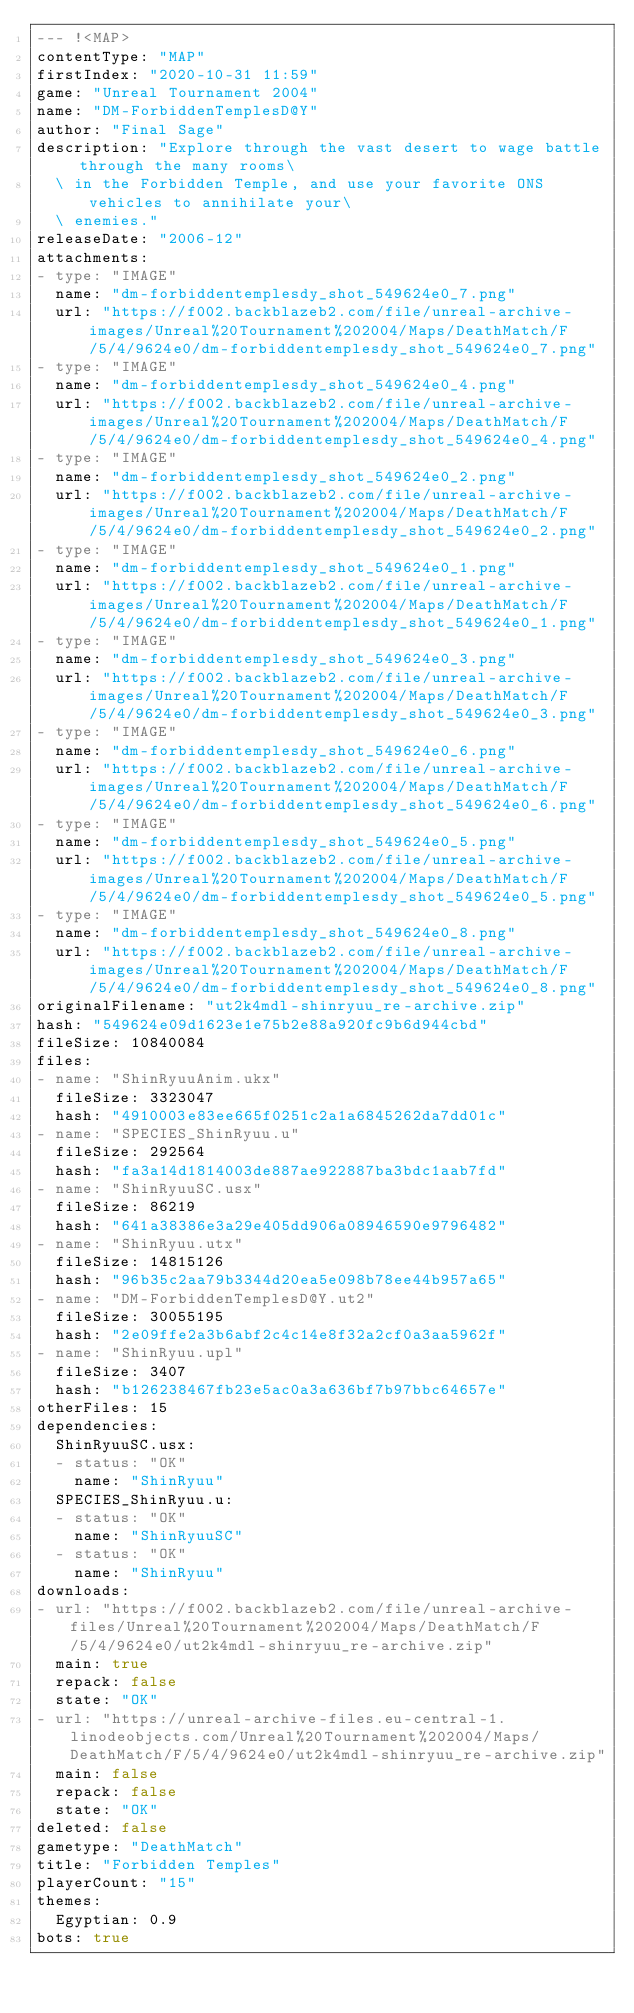<code> <loc_0><loc_0><loc_500><loc_500><_YAML_>--- !<MAP>
contentType: "MAP"
firstIndex: "2020-10-31 11:59"
game: "Unreal Tournament 2004"
name: "DM-ForbiddenTemplesD@Y"
author: "Final Sage"
description: "Explore through the vast desert to wage battle through the many rooms\
  \ in the Forbidden Temple, and use your favorite ONS vehicles to annihilate your\
  \ enemies."
releaseDate: "2006-12"
attachments:
- type: "IMAGE"
  name: "dm-forbiddentemplesdy_shot_549624e0_7.png"
  url: "https://f002.backblazeb2.com/file/unreal-archive-images/Unreal%20Tournament%202004/Maps/DeathMatch/F/5/4/9624e0/dm-forbiddentemplesdy_shot_549624e0_7.png"
- type: "IMAGE"
  name: "dm-forbiddentemplesdy_shot_549624e0_4.png"
  url: "https://f002.backblazeb2.com/file/unreal-archive-images/Unreal%20Tournament%202004/Maps/DeathMatch/F/5/4/9624e0/dm-forbiddentemplesdy_shot_549624e0_4.png"
- type: "IMAGE"
  name: "dm-forbiddentemplesdy_shot_549624e0_2.png"
  url: "https://f002.backblazeb2.com/file/unreal-archive-images/Unreal%20Tournament%202004/Maps/DeathMatch/F/5/4/9624e0/dm-forbiddentemplesdy_shot_549624e0_2.png"
- type: "IMAGE"
  name: "dm-forbiddentemplesdy_shot_549624e0_1.png"
  url: "https://f002.backblazeb2.com/file/unreal-archive-images/Unreal%20Tournament%202004/Maps/DeathMatch/F/5/4/9624e0/dm-forbiddentemplesdy_shot_549624e0_1.png"
- type: "IMAGE"
  name: "dm-forbiddentemplesdy_shot_549624e0_3.png"
  url: "https://f002.backblazeb2.com/file/unreal-archive-images/Unreal%20Tournament%202004/Maps/DeathMatch/F/5/4/9624e0/dm-forbiddentemplesdy_shot_549624e0_3.png"
- type: "IMAGE"
  name: "dm-forbiddentemplesdy_shot_549624e0_6.png"
  url: "https://f002.backblazeb2.com/file/unreal-archive-images/Unreal%20Tournament%202004/Maps/DeathMatch/F/5/4/9624e0/dm-forbiddentemplesdy_shot_549624e0_6.png"
- type: "IMAGE"
  name: "dm-forbiddentemplesdy_shot_549624e0_5.png"
  url: "https://f002.backblazeb2.com/file/unreal-archive-images/Unreal%20Tournament%202004/Maps/DeathMatch/F/5/4/9624e0/dm-forbiddentemplesdy_shot_549624e0_5.png"
- type: "IMAGE"
  name: "dm-forbiddentemplesdy_shot_549624e0_8.png"
  url: "https://f002.backblazeb2.com/file/unreal-archive-images/Unreal%20Tournament%202004/Maps/DeathMatch/F/5/4/9624e0/dm-forbiddentemplesdy_shot_549624e0_8.png"
originalFilename: "ut2k4mdl-shinryuu_re-archive.zip"
hash: "549624e09d1623e1e75b2e88a920fc9b6d944cbd"
fileSize: 10840084
files:
- name: "ShinRyuuAnim.ukx"
  fileSize: 3323047
  hash: "4910003e83ee665f0251c2a1a6845262da7dd01c"
- name: "SPECIES_ShinRyuu.u"
  fileSize: 292564
  hash: "fa3a14d1814003de887ae922887ba3bdc1aab7fd"
- name: "ShinRyuuSC.usx"
  fileSize: 86219
  hash: "641a38386e3a29e405dd906a08946590e9796482"
- name: "ShinRyuu.utx"
  fileSize: 14815126
  hash: "96b35c2aa79b3344d20ea5e098b78ee44b957a65"
- name: "DM-ForbiddenTemplesD@Y.ut2"
  fileSize: 30055195
  hash: "2e09ffe2a3b6abf2c4c14e8f32a2cf0a3aa5962f"
- name: "ShinRyuu.upl"
  fileSize: 3407
  hash: "b126238467fb23e5ac0a3a636bf7b97bbc64657e"
otherFiles: 15
dependencies:
  ShinRyuuSC.usx:
  - status: "OK"
    name: "ShinRyuu"
  SPECIES_ShinRyuu.u:
  - status: "OK"
    name: "ShinRyuuSC"
  - status: "OK"
    name: "ShinRyuu"
downloads:
- url: "https://f002.backblazeb2.com/file/unreal-archive-files/Unreal%20Tournament%202004/Maps/DeathMatch/F/5/4/9624e0/ut2k4mdl-shinryuu_re-archive.zip"
  main: true
  repack: false
  state: "OK"
- url: "https://unreal-archive-files.eu-central-1.linodeobjects.com/Unreal%20Tournament%202004/Maps/DeathMatch/F/5/4/9624e0/ut2k4mdl-shinryuu_re-archive.zip"
  main: false
  repack: false
  state: "OK"
deleted: false
gametype: "DeathMatch"
title: "Forbidden Temples"
playerCount: "15"
themes:
  Egyptian: 0.9
bots: true
</code> 